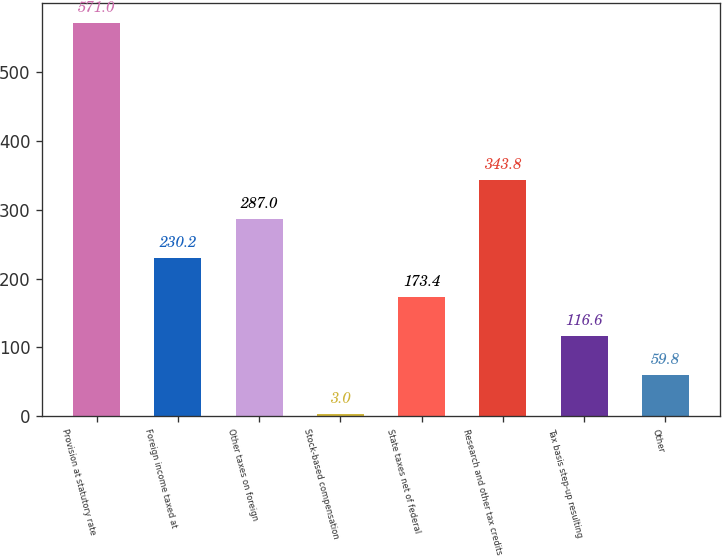<chart> <loc_0><loc_0><loc_500><loc_500><bar_chart><fcel>Provision at statutory rate<fcel>Foreign income taxed at<fcel>Other taxes on foreign<fcel>Stock-based compensation<fcel>State taxes net of federal<fcel>Research and other tax credits<fcel>Tax basis step-up resulting<fcel>Other<nl><fcel>571<fcel>230.2<fcel>287<fcel>3<fcel>173.4<fcel>343.8<fcel>116.6<fcel>59.8<nl></chart> 